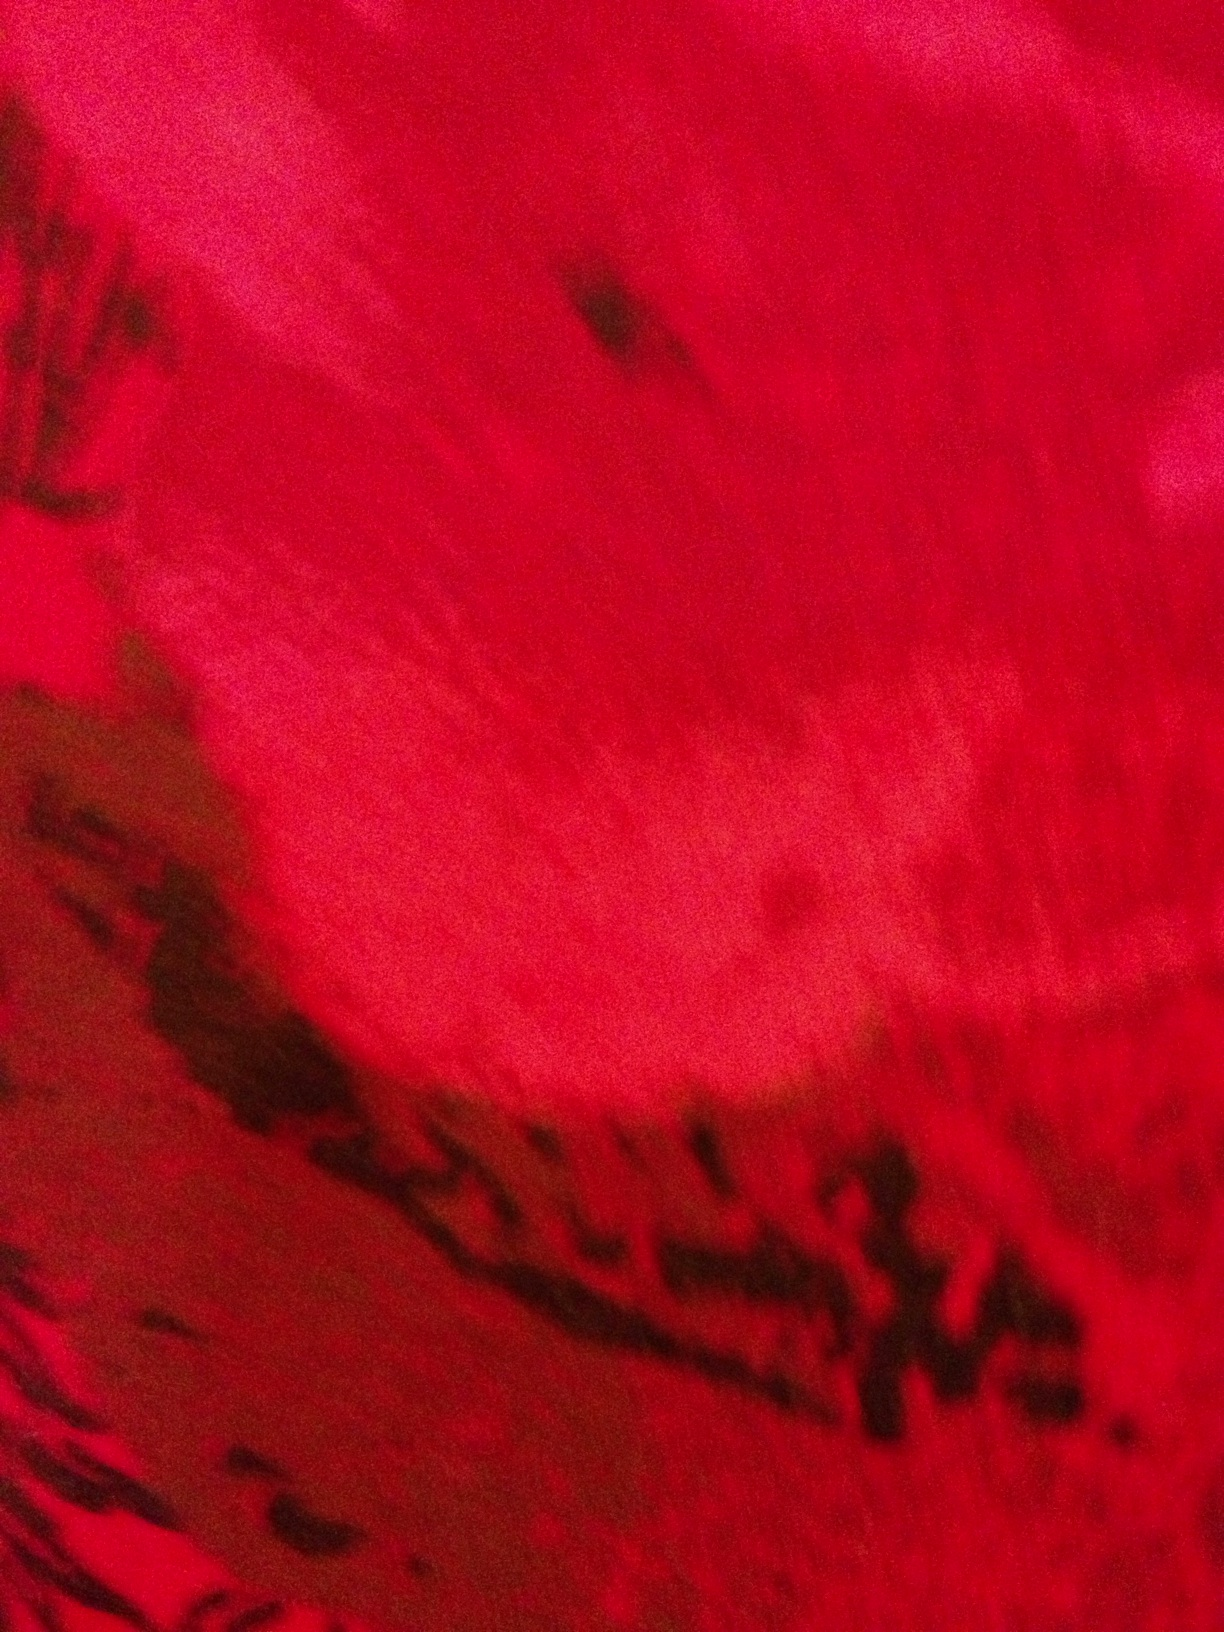What does this look like? The image appears to be a close-up of a red, textured surface, possibly a natural material like a flower petal or an abstract painting. The texture suggests a soft yet uneven surface with darker mottled patches that give it a vibrant and dynamic appearance. 